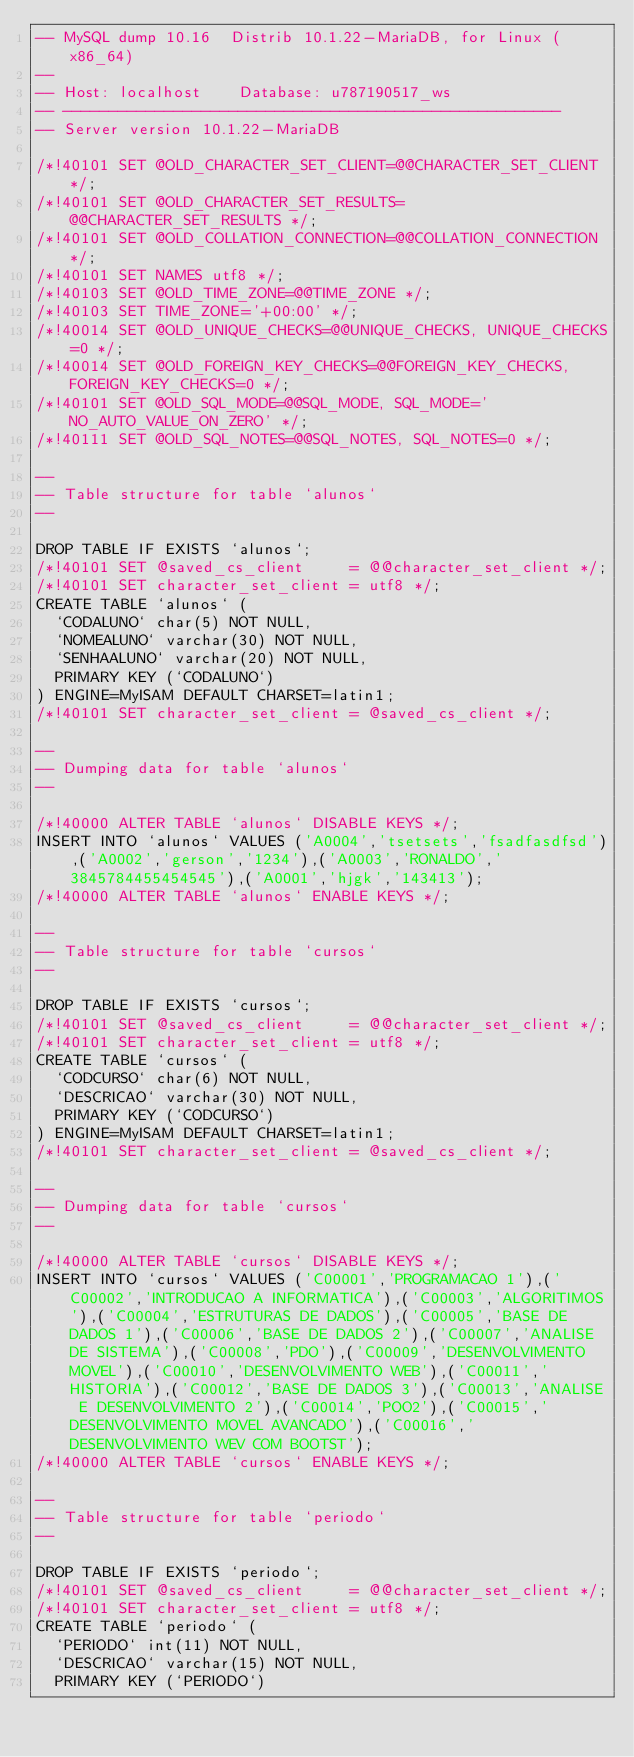Convert code to text. <code><loc_0><loc_0><loc_500><loc_500><_SQL_>-- MySQL dump 10.16  Distrib 10.1.22-MariaDB, for Linux (x86_64)
--
-- Host: localhost    Database: u787190517_ws
-- ------------------------------------------------------
-- Server version	10.1.22-MariaDB

/*!40101 SET @OLD_CHARACTER_SET_CLIENT=@@CHARACTER_SET_CLIENT */;
/*!40101 SET @OLD_CHARACTER_SET_RESULTS=@@CHARACTER_SET_RESULTS */;
/*!40101 SET @OLD_COLLATION_CONNECTION=@@COLLATION_CONNECTION */;
/*!40101 SET NAMES utf8 */;
/*!40103 SET @OLD_TIME_ZONE=@@TIME_ZONE */;
/*!40103 SET TIME_ZONE='+00:00' */;
/*!40014 SET @OLD_UNIQUE_CHECKS=@@UNIQUE_CHECKS, UNIQUE_CHECKS=0 */;
/*!40014 SET @OLD_FOREIGN_KEY_CHECKS=@@FOREIGN_KEY_CHECKS, FOREIGN_KEY_CHECKS=0 */;
/*!40101 SET @OLD_SQL_MODE=@@SQL_MODE, SQL_MODE='NO_AUTO_VALUE_ON_ZERO' */;
/*!40111 SET @OLD_SQL_NOTES=@@SQL_NOTES, SQL_NOTES=0 */;

--
-- Table structure for table `alunos`
--

DROP TABLE IF EXISTS `alunos`;
/*!40101 SET @saved_cs_client     = @@character_set_client */;
/*!40101 SET character_set_client = utf8 */;
CREATE TABLE `alunos` (
  `CODALUNO` char(5) NOT NULL,
  `NOMEALUNO` varchar(30) NOT NULL,
  `SENHAALUNO` varchar(20) NOT NULL,
  PRIMARY KEY (`CODALUNO`)
) ENGINE=MyISAM DEFAULT CHARSET=latin1;
/*!40101 SET character_set_client = @saved_cs_client */;

--
-- Dumping data for table `alunos`
--

/*!40000 ALTER TABLE `alunos` DISABLE KEYS */;
INSERT INTO `alunos` VALUES ('A0004','tsetsets','fsadfasdfsd'),('A0002','gerson','1234'),('A0003','RONALDO','3845784455454545'),('A0001','hjgk','143413');
/*!40000 ALTER TABLE `alunos` ENABLE KEYS */;

--
-- Table structure for table `cursos`
--

DROP TABLE IF EXISTS `cursos`;
/*!40101 SET @saved_cs_client     = @@character_set_client */;
/*!40101 SET character_set_client = utf8 */;
CREATE TABLE `cursos` (
  `CODCURSO` char(6) NOT NULL,
  `DESCRICAO` varchar(30) NOT NULL,
  PRIMARY KEY (`CODCURSO`)
) ENGINE=MyISAM DEFAULT CHARSET=latin1;
/*!40101 SET character_set_client = @saved_cs_client */;

--
-- Dumping data for table `cursos`
--

/*!40000 ALTER TABLE `cursos` DISABLE KEYS */;
INSERT INTO `cursos` VALUES ('C00001','PROGRAMACAO 1'),('C00002','INTRODUCAO A INFORMATICA'),('C00003','ALGORITIMOS'),('C00004','ESTRUTURAS DE DADOS'),('C00005','BASE DE DADOS 1'),('C00006','BASE DE DADOS 2'),('C00007','ANALISE DE SISTEMA'),('C00008','PDO'),('C00009','DESENVOLVIMENTO MOVEL'),('C00010','DESENVOLVIMENTO WEB'),('C00011','HISTORIA'),('C00012','BASE DE DADOS 3'),('C00013','ANALISE E DESENVOLVIMENTO 2'),('C00014','POO2'),('C00015','DESENVOLVIMENTO MOVEL AVANCADO'),('C00016','DESENVOLVIMENTO WEV COM BOOTST');
/*!40000 ALTER TABLE `cursos` ENABLE KEYS */;

--
-- Table structure for table `periodo`
--

DROP TABLE IF EXISTS `periodo`;
/*!40101 SET @saved_cs_client     = @@character_set_client */;
/*!40101 SET character_set_client = utf8 */;
CREATE TABLE `periodo` (
  `PERIODO` int(11) NOT NULL,
  `DESCRICAO` varchar(15) NOT NULL,
  PRIMARY KEY (`PERIODO`)</code> 